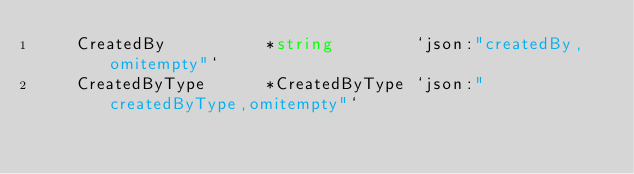<code> <loc_0><loc_0><loc_500><loc_500><_Go_>	CreatedBy          *string        `json:"createdBy,omitempty"`
	CreatedByType      *CreatedByType `json:"createdByType,omitempty"`</code> 